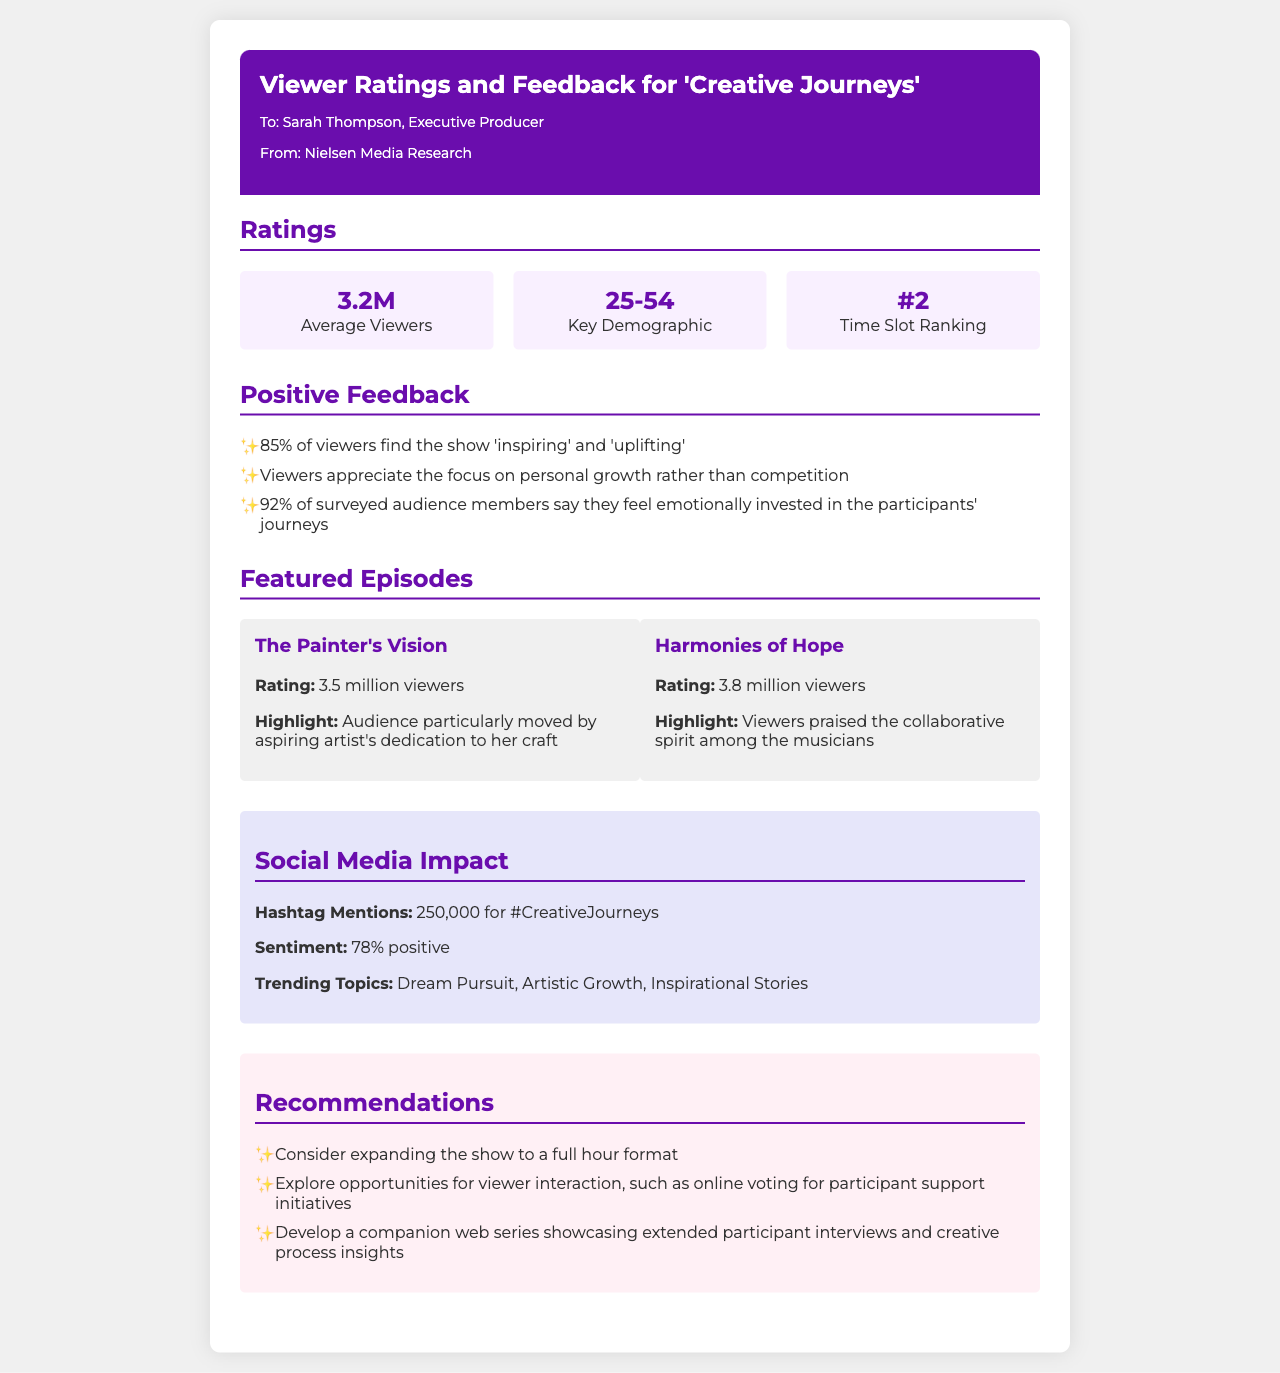What is the average number of viewers for 'Creative Journeys'? The average number of viewers is clearly stated in the ratings section of the document as 3.2 million.
Answer: 3.2M What percentage of viewers found the show inspiring? The document mentions that 85% of viewers find the show 'inspiring' and 'uplifting', which addresses the specific inquiry about viewer sentiment.
Answer: 85% What is the time slot ranking for 'Creative Journeys'? According to the ratings section, the show ranks #2 in its time slot, providing specific ranking information.
Answer: #2 Which episode received the highest viewership? The document lists the ratings for each featured episode, indicating that 'Harmonies of Hope' had the highest viewership at 3.8 million.
Answer: Harmonies of Hope What does the social media sentiment percentage indicate? The document states that the sentiment related to social media mentions is 78% positive, reflecting overall viewer reception on social platforms.
Answer: 78% positive What recommendation is made regarding the show's format? The document suggests expanding the show to a full hour format, which is a specific recommendation for potential improvement.
Answer: Full hour format Why do viewers appreciate the show? Viewers appreciate the focus on personal growth rather than competition, which highlights the core appeal of the series according to viewer feedback.
Answer: Personal growth What is the trending topic associated with 'Creative Journeys'? The document lists several trending topics, one of which is 'Dream Pursuit', indicating popular themes associated with the show.
Answer: Dream Pursuit 